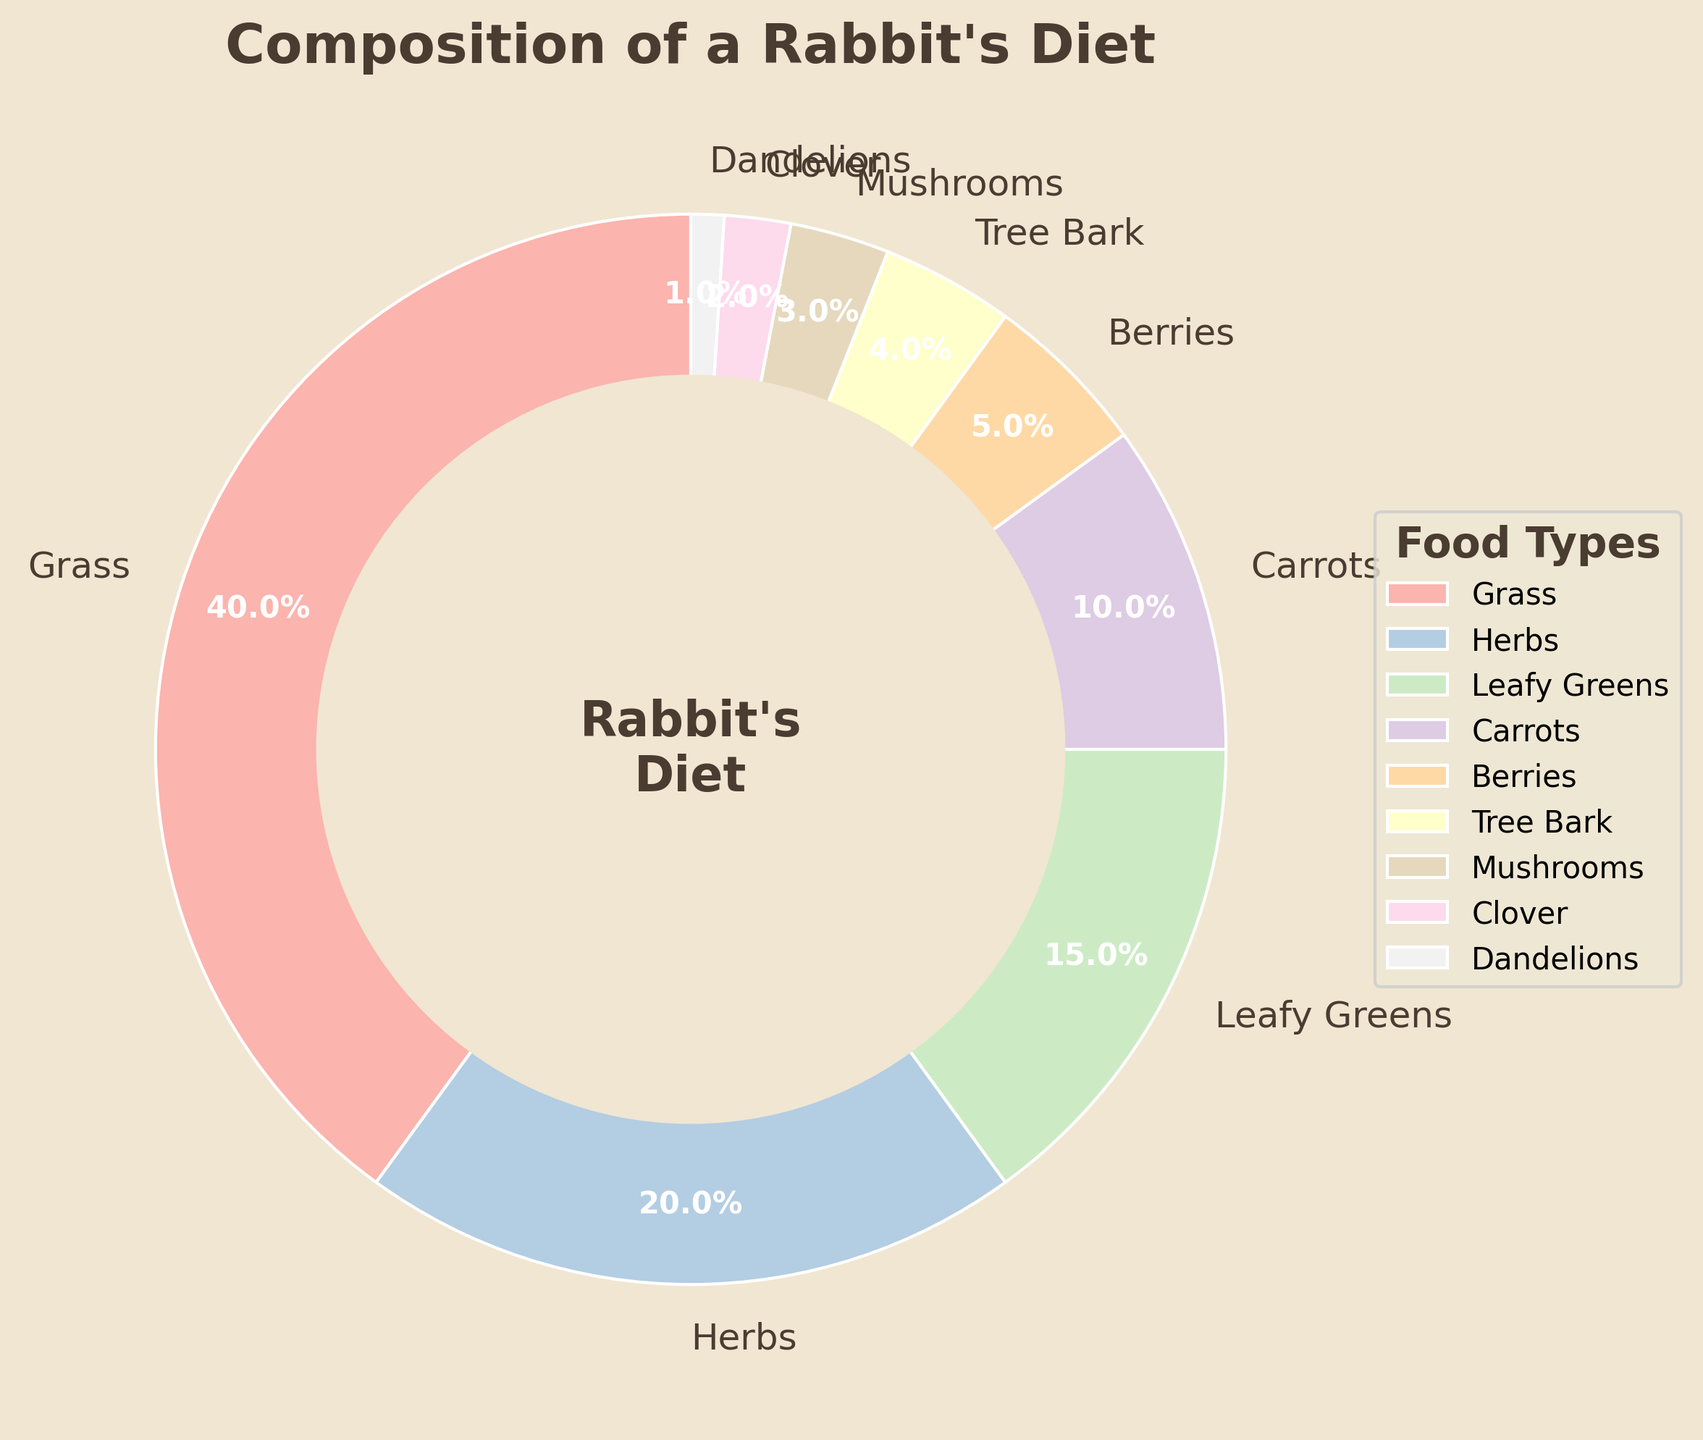What is the percentage of the diet that consists of Grass and Herbs combined? To find the combined percentage of Grass and Herbs, add their individual percentages: Grass (40%) + Herbs (20%) = 60%
Answer: 60% Which food types make up more than 10% of the rabbit's diet? Identify the food types with percentages greater than 10% by inspecting the chart: Grass (40%), Herbs (20%), and Leafy Greens (15%)
Answer: Grass, Herbs, Leafy Greens How much more significant is Grass in the diet than Carrots? Calculate the difference between the percentages of Grass and Carrots: Grass (40%) - Carrots (10%) = 30%
Answer: 30% Which food type has the smallest contribution to the rabbit's diet? Find the food type with the smallest percentage by examining the chart: Dandelions (1%)
Answer: Dandelions Is the combined percentage of Mushrooms and Clover greater than the percentage of Berries? Compare the sum of Mushrooms and Clover with Berries: Mushrooms (3%) + Clover (2%) = 5% which equals the Berries' percentage (5%)
Answer: No, it equals What percentage of the diet consists of Tree Bark and Berries combined? Add the percentages of Tree Bark and Berries: Tree Bark (4%) + Berries (5%) = 9%
Answer: 9% How many food types contribute 10% or more to the diet? Count the food types with percentages 10% or more: Grass (40%), Herbs (20%), Leafy Greens (15%), Carrots (10%) = 4 food types
Answer: 4 What is the difference in percentage between the food type with the highest and the food type with the lowest contributions? Calculate the difference between the highest (Grass, 40%) and the lowest (Dandelions, 1%): 40% - 1% = 39%
Answer: 39% What is the average percentage of the top 3 contributing food types? To find the average, sum the percentages of the top 3 food types and divide by 3: (Grass 40% + Herbs 20% + Leafy Greens 15%) / 3 = 75% / 3 = 25%
Answer: 25% Is the percentage of Carrots greater than or less than three times the percentage of Clover? Calculate three times the percentage of Clover and compare it with the percentage of Carrots: 3 * Clover (2%) = 6%; Carrots (10%) is greater
Answer: Greater 